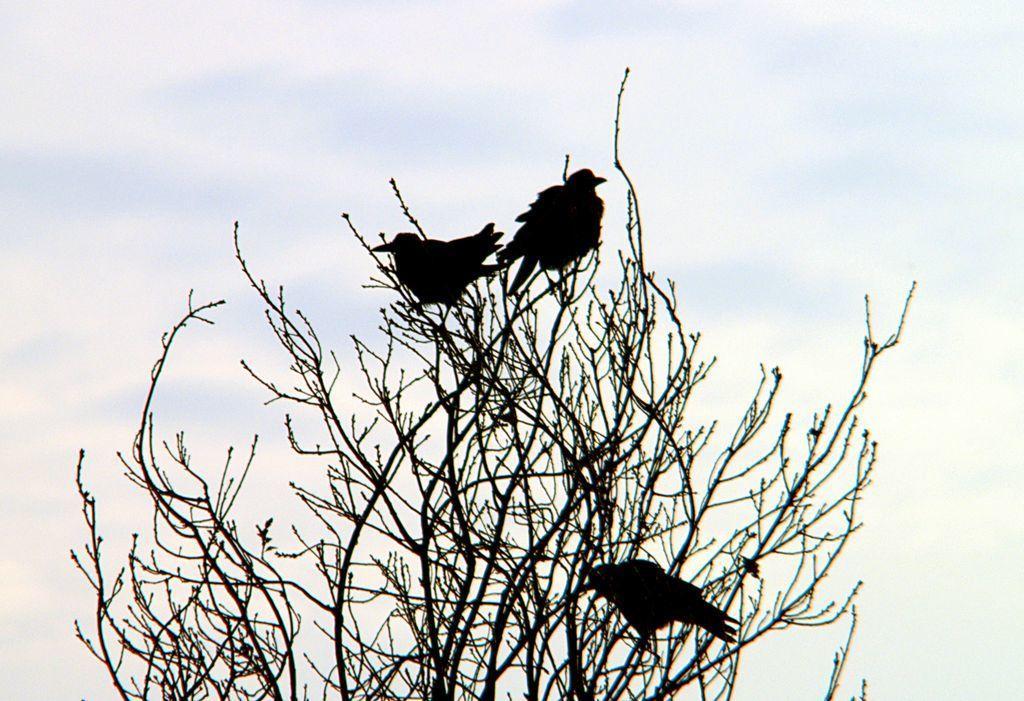In one or two sentences, can you explain what this image depicts? In this image there are three birds sitting on a tree as we can see in the bottom of this image and there is a sky in the background. 